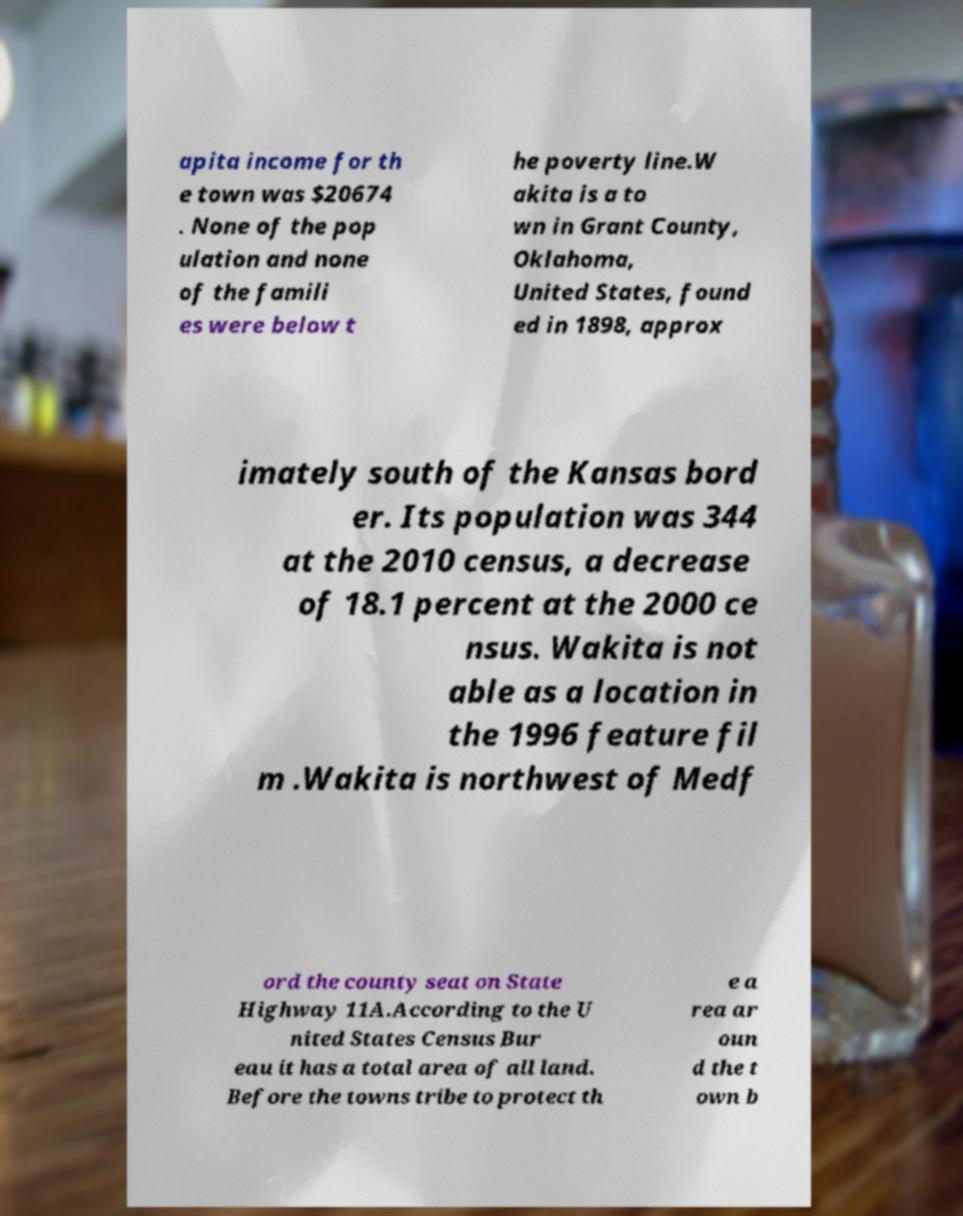There's text embedded in this image that I need extracted. Can you transcribe it verbatim? apita income for th e town was $20674 . None of the pop ulation and none of the famili es were below t he poverty line.W akita is a to wn in Grant County, Oklahoma, United States, found ed in 1898, approx imately south of the Kansas bord er. Its population was 344 at the 2010 census, a decrease of 18.1 percent at the 2000 ce nsus. Wakita is not able as a location in the 1996 feature fil m .Wakita is northwest of Medf ord the county seat on State Highway 11A.According to the U nited States Census Bur eau it has a total area of all land. Before the towns tribe to protect th e a rea ar oun d the t own b 